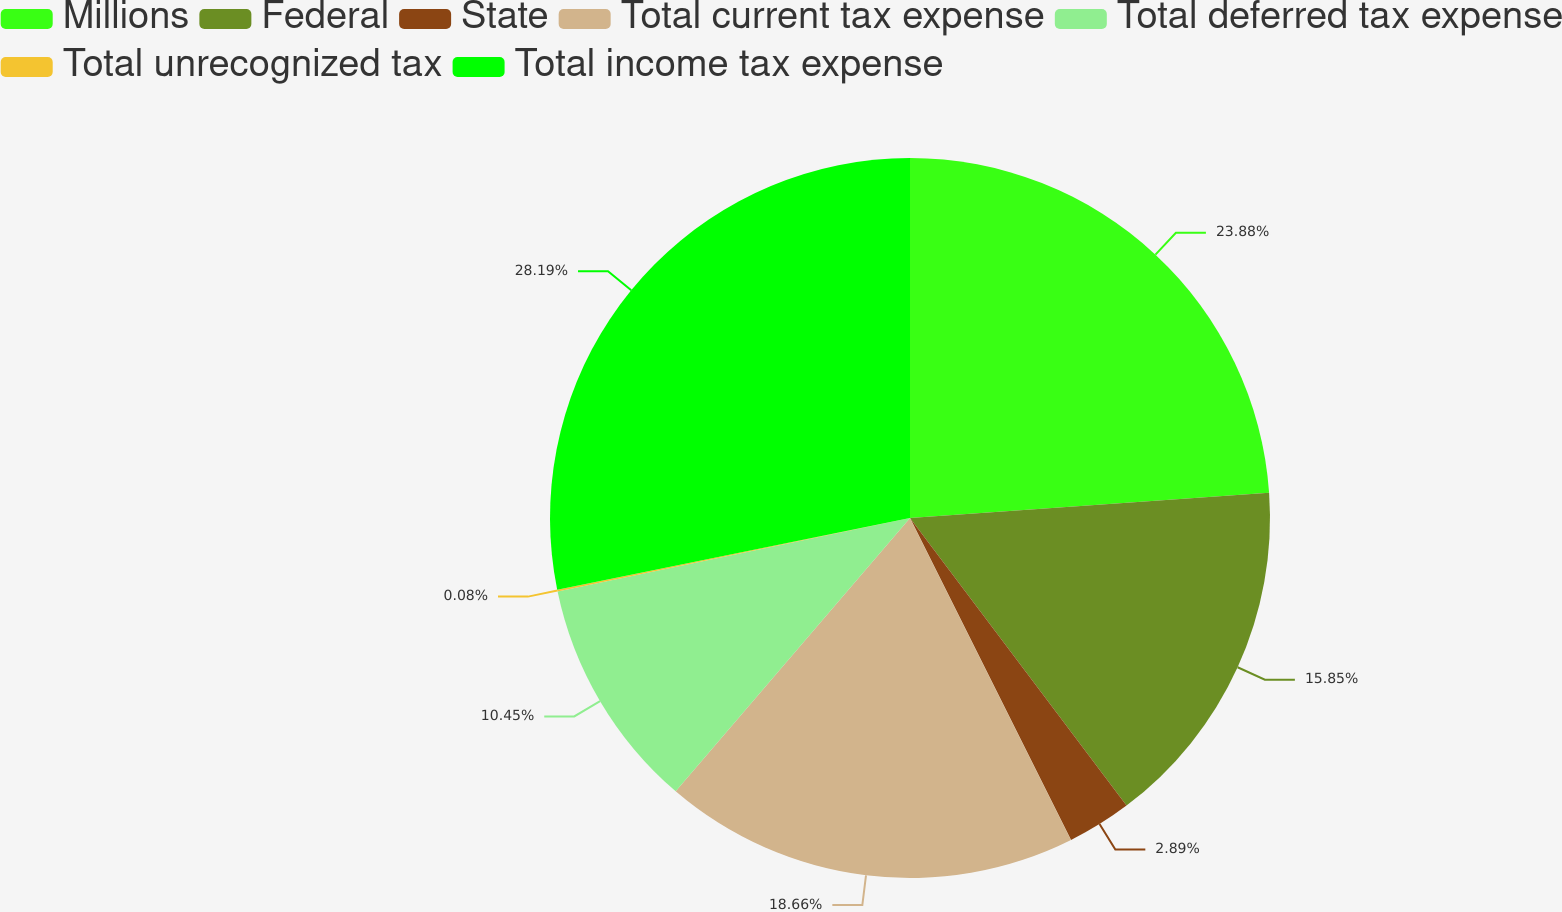Convert chart. <chart><loc_0><loc_0><loc_500><loc_500><pie_chart><fcel>Millions<fcel>Federal<fcel>State<fcel>Total current tax expense<fcel>Total deferred tax expense<fcel>Total unrecognized tax<fcel>Total income tax expense<nl><fcel>23.88%<fcel>15.85%<fcel>2.89%<fcel>18.66%<fcel>10.45%<fcel>0.08%<fcel>28.19%<nl></chart> 